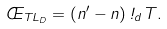Convert formula to latex. <formula><loc_0><loc_0><loc_500><loc_500>\phi _ { T L _ { D } } = \left ( n ^ { \prime } - n \right ) \omega _ { d } T .</formula> 